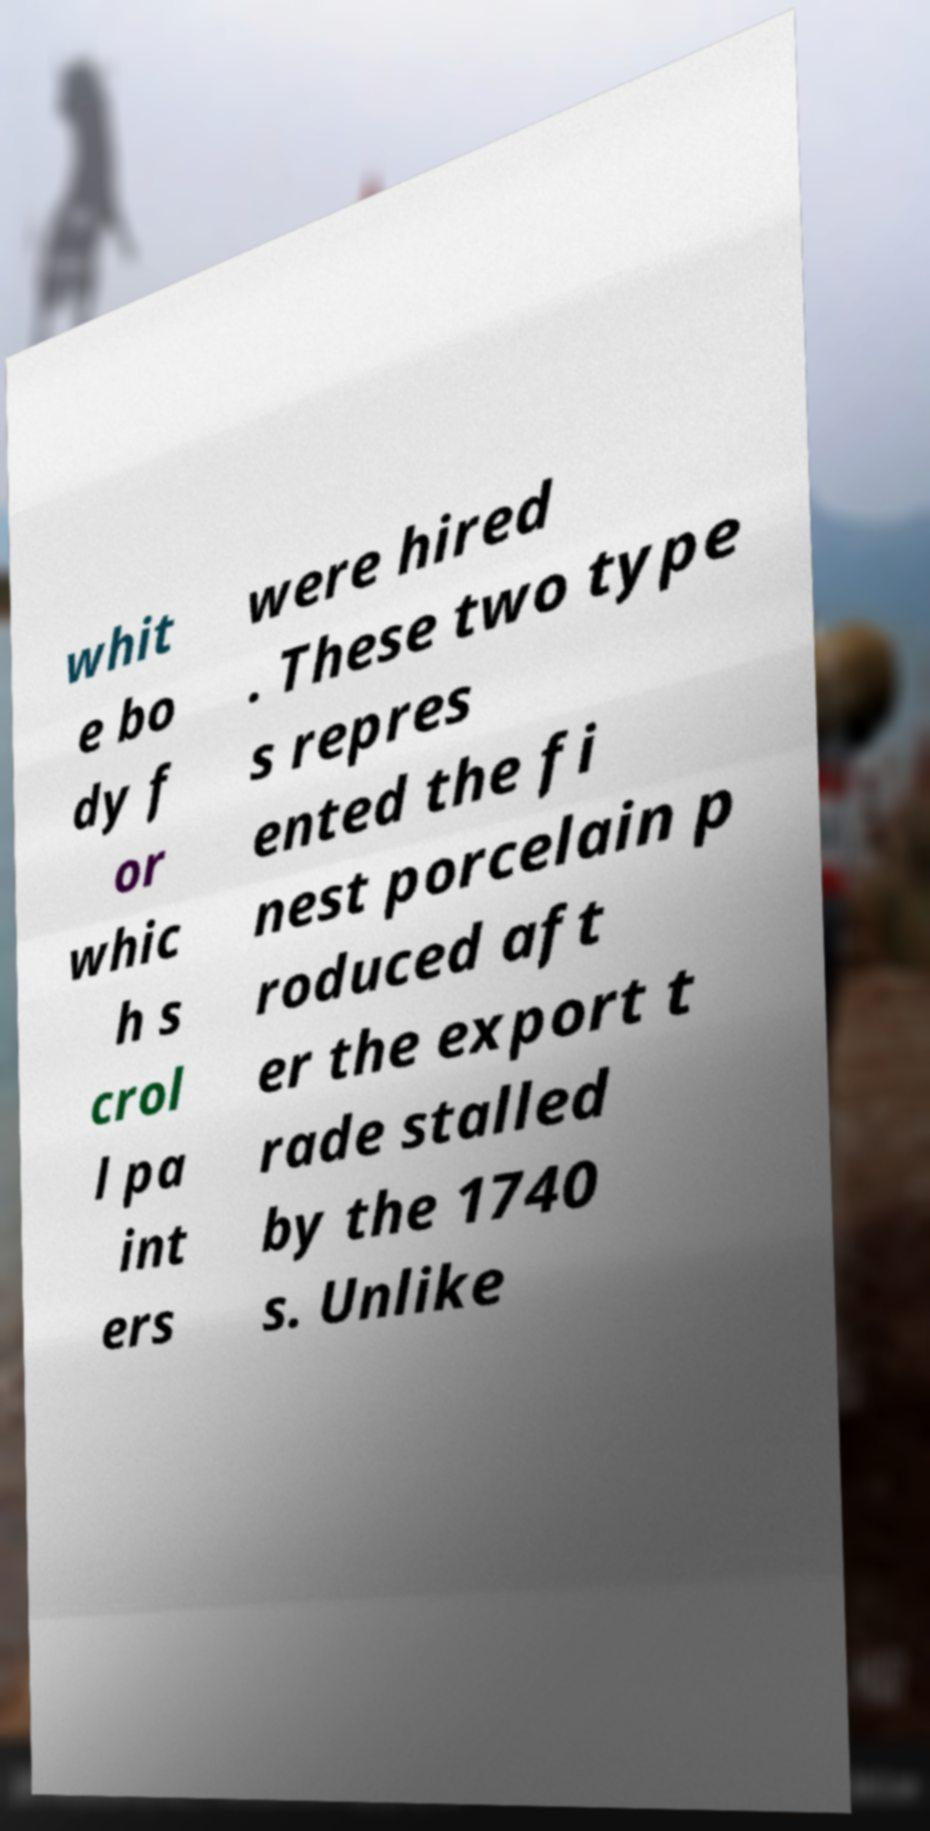Please read and relay the text visible in this image. What does it say? whit e bo dy f or whic h s crol l pa int ers were hired . These two type s repres ented the fi nest porcelain p roduced aft er the export t rade stalled by the 1740 s. Unlike 